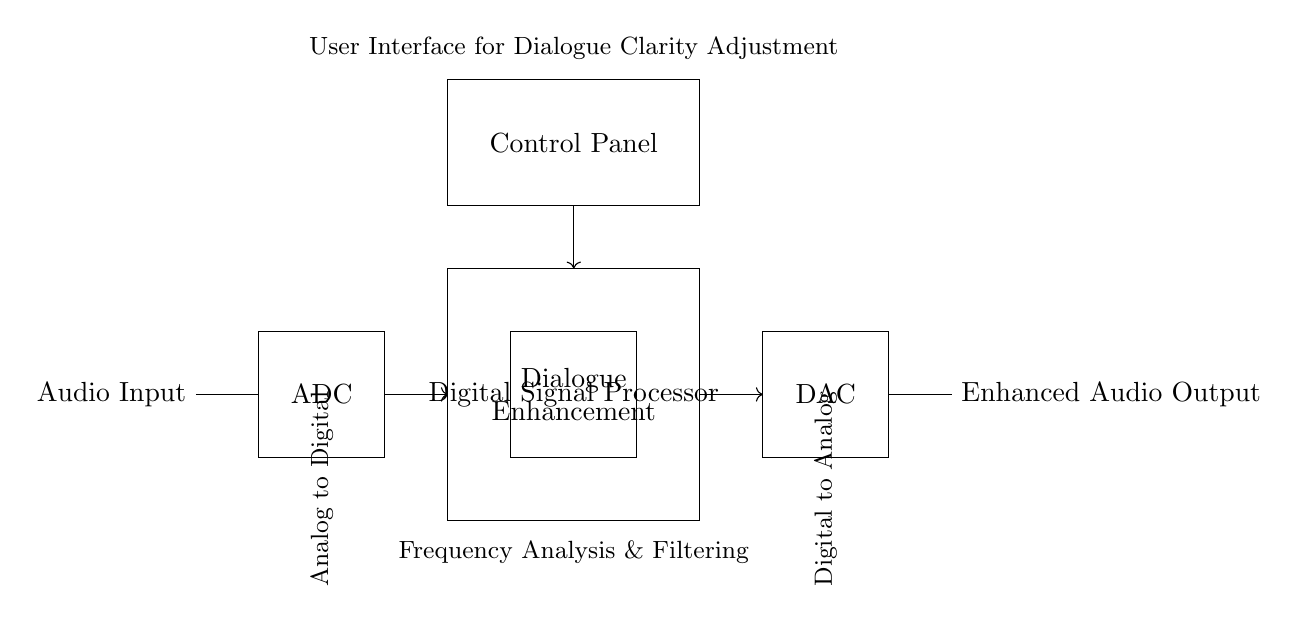What type of input does this circuit receive? The circuit receives an audio input, indicated by the label next to the initial connection point.
Answer: Audio Input What is the function of the ADC in this circuit? The ADC (Analog to Digital Converter) converts the analog audio input into a digital signal for processing. This is essential for digital audio processing, which cannot handle analog signals directly.
Answer: Conversion What does the Dialogue Enhancement block do? The Dialogue Enhancement block processes the digital signal specifically to improve the clarity of speech within the audio, resulting in clearer dialogue in films.
Answer: Enhance dialogue What is the purpose of the DAC in this circuit? The DAC (Digital to Analog Converter) converts the processed digital signal back into an analog format that can be outputted as audio, allowing it to be played through standard audio systems.
Answer: Conversion How many main processing components are in the circuit? The circuit consists of three main processing components: ADC, Digital Signal Processor, and DAC. Their sequence supports the audio enhancement process from input to output.
Answer: Three What does the Control Panel allow the user to adjust? The Control Panel provides a user interface for dialogue clarity adjustments, enabling the operator to modify the audio processing parameters positively impacting dialogue enhancement effectiveness.
Answer: Dialogue clarity adjustment What type of processing does the Digital Signal Processor perform? The Digital Signal Processor performs frequency analysis and filtering, enabling it to manipulate the digital audio signal and enhance particular aspects of the sound, especially dialogue.
Answer: Filtering and analysis 